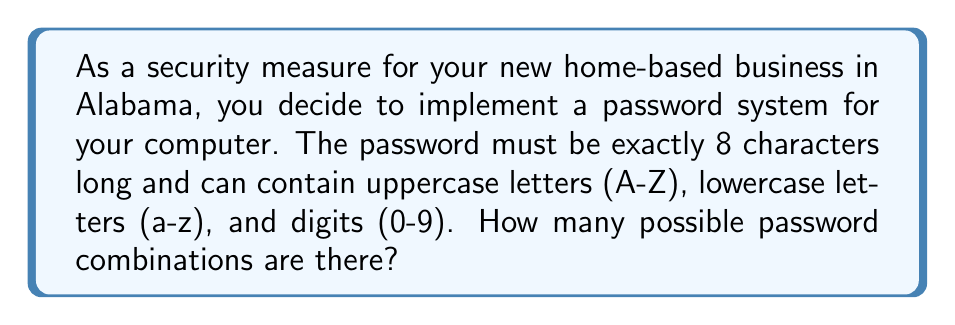Could you help me with this problem? Let's approach this step-by-step:

1) First, we need to count the number of possible characters:
   - 26 uppercase letters
   - 26 lowercase letters
   - 10 digits
   Total: 26 + 26 + 10 = 62 possible characters

2) For each of the 8 positions in the password, we have 62 choices.

3) This is a case of the Multiplication Principle. When we have a series of independent choices, we multiply the number of possibilities for each choice.

4) Therefore, the total number of possible passwords is:

   $$ 62 \times 62 \times 62 \times 62 \times 62 \times 62 \times 62 \times 62 $$

5) This can be written as an exponent:

   $$ 62^8 $$

6) Calculating this:
   $$ 62^8 = 218,340,105,584,896 $$

This large number demonstrates why using a combination of uppercase, lowercase, and digits in a password of sufficient length provides good security for your business data.
Answer: $218,340,105,584,896$ 